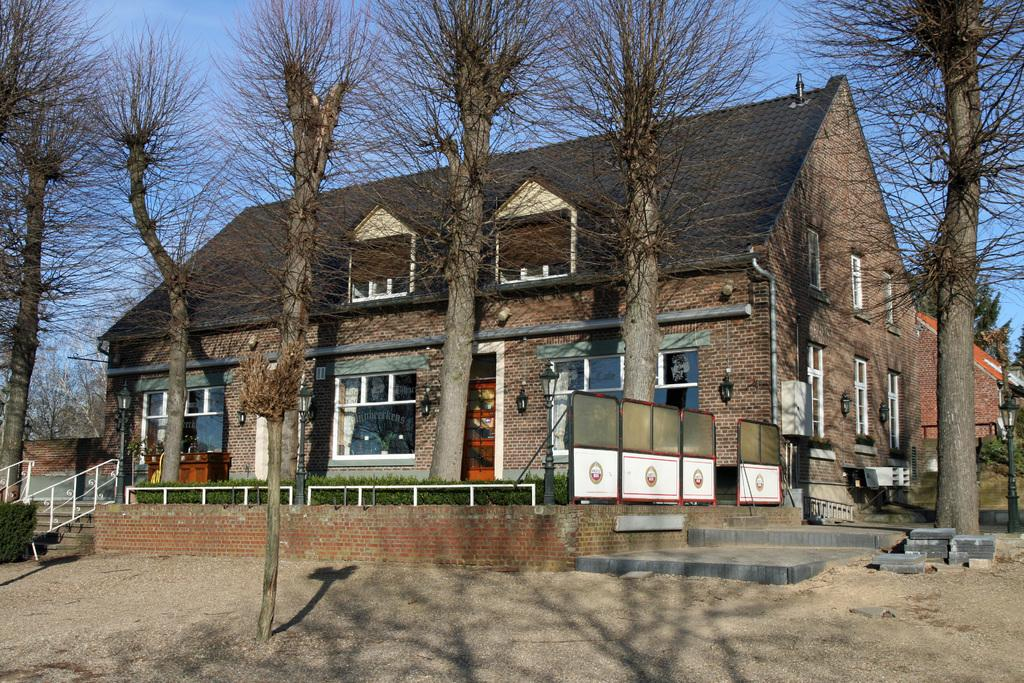What type of structure is present in the image? There is a building in the image. What can be seen in the background of the image? There are trees visible in the image. What is on the wall of the building? There are lights on the wall. What type of windows are on the building? There are glass windows on the building. What type of vegetation is present in the image? There is a plant in the image. What can be seen in the sky in the image? Stars are visible in the sky, and the sky is blue. What type of locket is hanging from the tree in the image? There is no locket hanging from the tree in the image; only trees and a plant are present. What type of maid is visible in the image? There is no maid present in the image. 